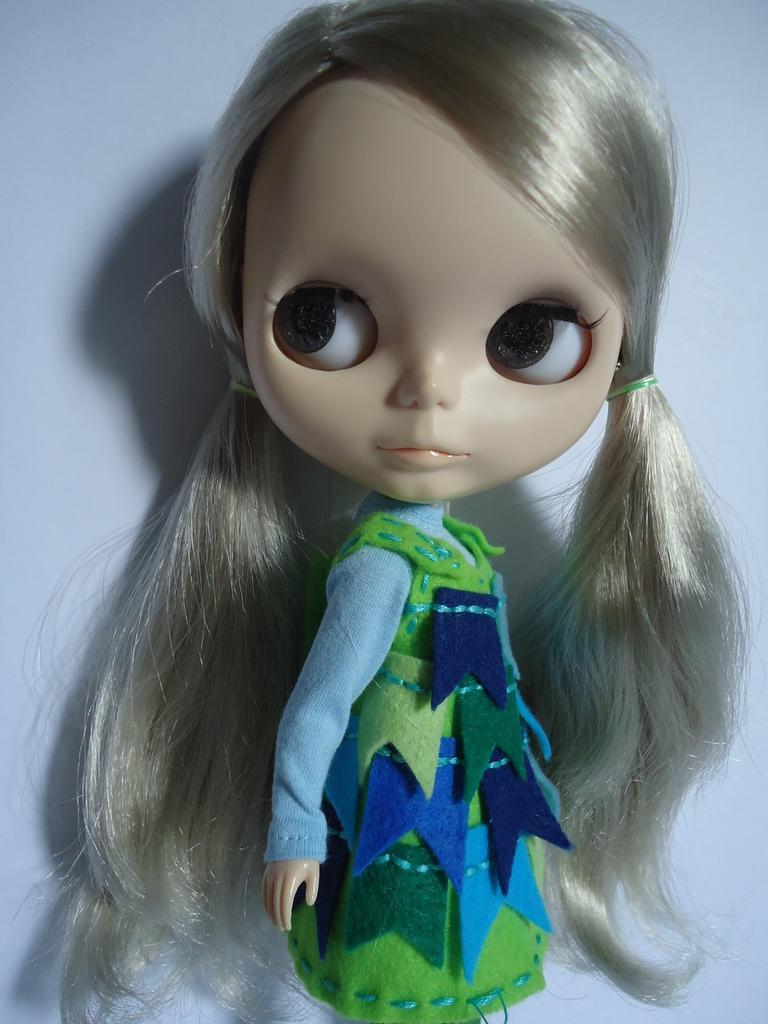Describe this image in one or two sentences. In this image we can see there is a doll with white background. 